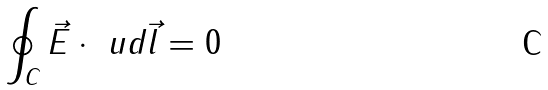<formula> <loc_0><loc_0><loc_500><loc_500>\oint _ { C } \vec { E } \cdot \ u d \vec { l } = 0</formula> 